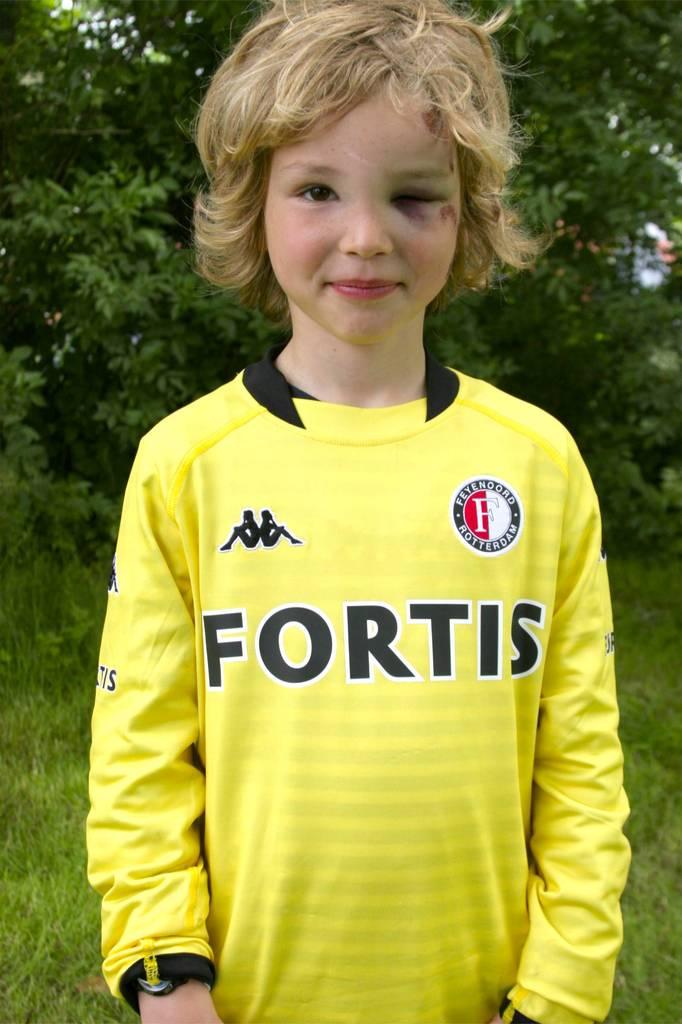Who is the sponsor on that jersey?
Provide a short and direct response. Fortis. What team is this jersey for?
Your answer should be compact. Fortis. 